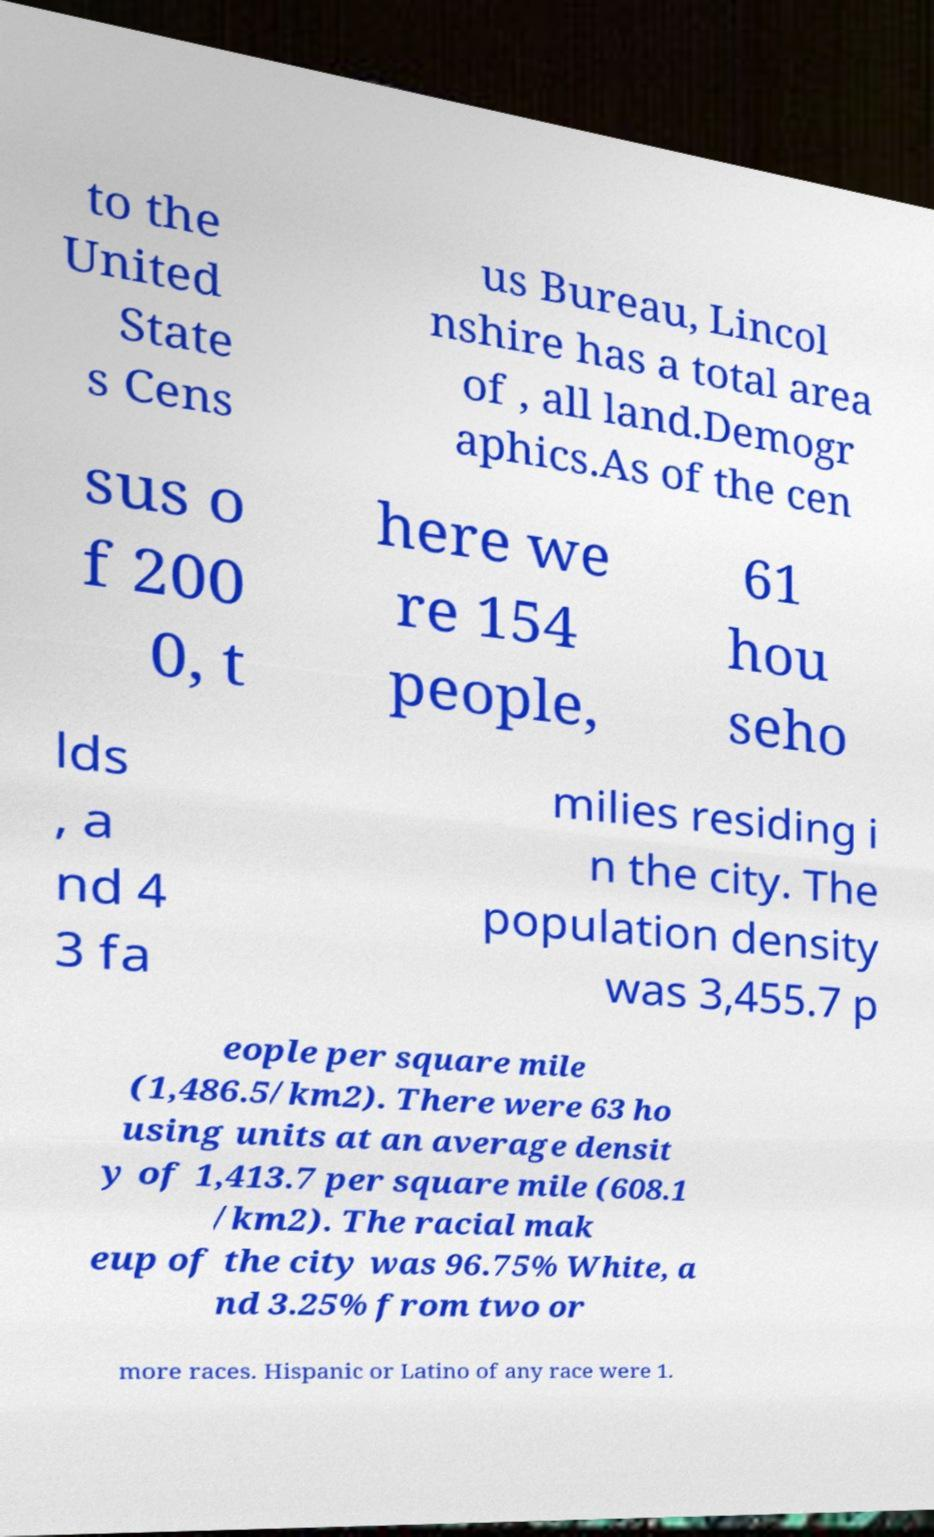Can you read and provide the text displayed in the image?This photo seems to have some interesting text. Can you extract and type it out for me? to the United State s Cens us Bureau, Lincol nshire has a total area of , all land.Demogr aphics.As of the cen sus o f 200 0, t here we re 154 people, 61 hou seho lds , a nd 4 3 fa milies residing i n the city. The population density was 3,455.7 p eople per square mile (1,486.5/km2). There were 63 ho using units at an average densit y of 1,413.7 per square mile (608.1 /km2). The racial mak eup of the city was 96.75% White, a nd 3.25% from two or more races. Hispanic or Latino of any race were 1. 